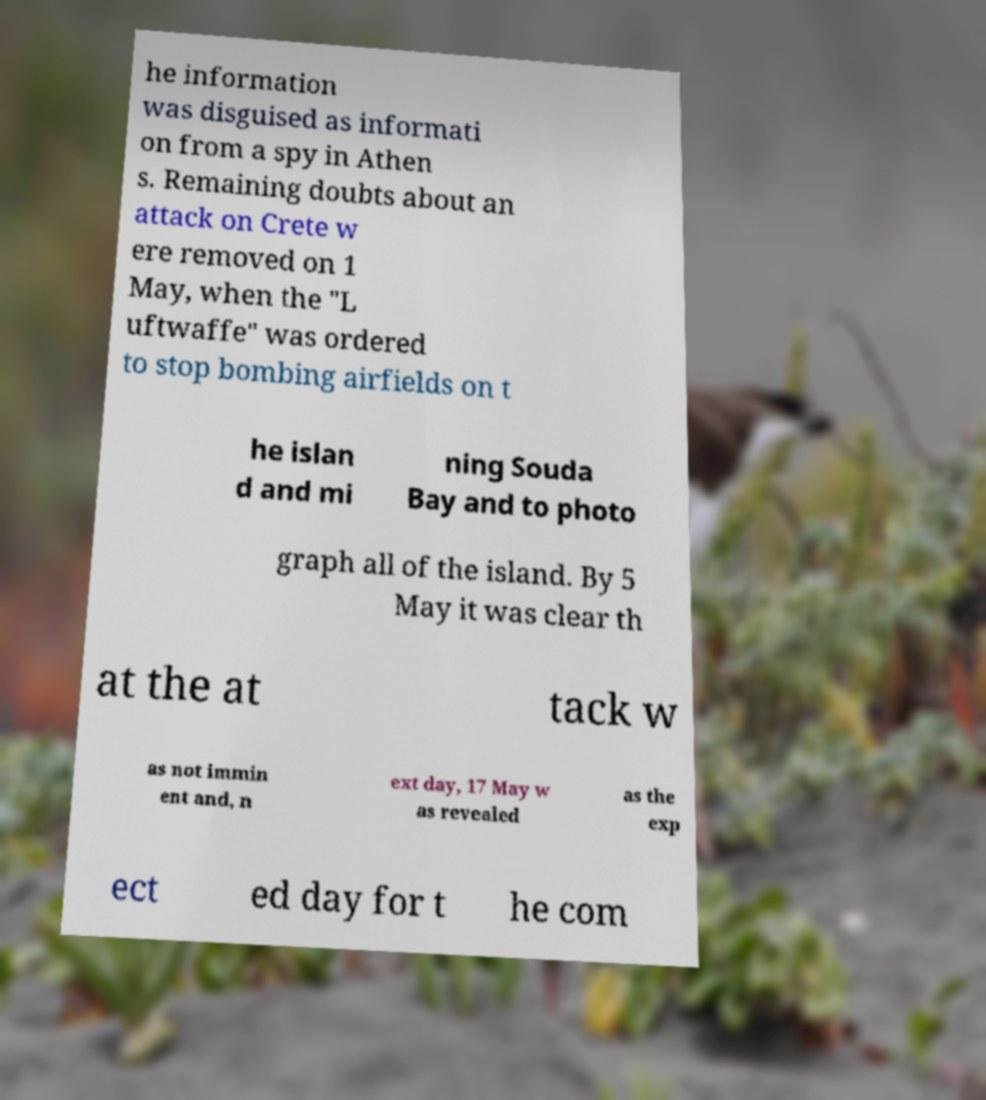There's text embedded in this image that I need extracted. Can you transcribe it verbatim? he information was disguised as informati on from a spy in Athen s. Remaining doubts about an attack on Crete w ere removed on 1 May, when the "L uftwaffe" was ordered to stop bombing airfields on t he islan d and mi ning Souda Bay and to photo graph all of the island. By 5 May it was clear th at the at tack w as not immin ent and, n ext day, 17 May w as revealed as the exp ect ed day for t he com 